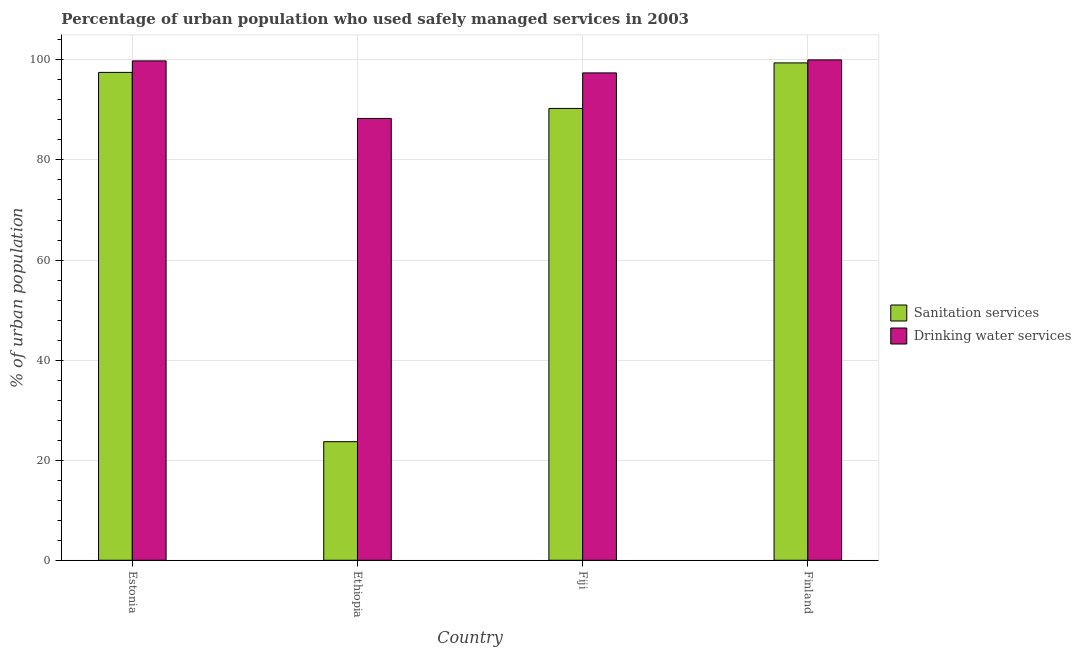What is the label of the 2nd group of bars from the left?
Offer a terse response. Ethiopia. What is the percentage of urban population who used sanitation services in Fiji?
Your answer should be compact. 90.3. Across all countries, what is the maximum percentage of urban population who used drinking water services?
Offer a very short reply. 100. Across all countries, what is the minimum percentage of urban population who used sanitation services?
Make the answer very short. 23.7. In which country was the percentage of urban population who used sanitation services minimum?
Offer a very short reply. Ethiopia. What is the total percentage of urban population who used drinking water services in the graph?
Keep it short and to the point. 385.5. What is the difference between the percentage of urban population who used drinking water services in Estonia and that in Fiji?
Provide a succinct answer. 2.4. What is the difference between the percentage of urban population who used sanitation services in Estonia and the percentage of urban population who used drinking water services in Finland?
Provide a succinct answer. -2.5. What is the average percentage of urban population who used sanitation services per country?
Provide a succinct answer. 77.72. What is the difference between the percentage of urban population who used sanitation services and percentage of urban population who used drinking water services in Fiji?
Offer a very short reply. -7.1. What is the ratio of the percentage of urban population who used sanitation services in Estonia to that in Ethiopia?
Offer a terse response. 4.11. Is the percentage of urban population who used sanitation services in Fiji less than that in Finland?
Your response must be concise. Yes. Is the difference between the percentage of urban population who used drinking water services in Ethiopia and Finland greater than the difference between the percentage of urban population who used sanitation services in Ethiopia and Finland?
Make the answer very short. Yes. What is the difference between the highest and the second highest percentage of urban population who used drinking water services?
Your response must be concise. 0.2. What is the difference between the highest and the lowest percentage of urban population who used drinking water services?
Your answer should be very brief. 11.7. What does the 1st bar from the left in Finland represents?
Your answer should be very brief. Sanitation services. What does the 1st bar from the right in Estonia represents?
Provide a succinct answer. Drinking water services. How many bars are there?
Provide a succinct answer. 8. How many countries are there in the graph?
Offer a terse response. 4. Are the values on the major ticks of Y-axis written in scientific E-notation?
Your answer should be compact. No. Does the graph contain any zero values?
Your answer should be very brief. No. What is the title of the graph?
Your response must be concise. Percentage of urban population who used safely managed services in 2003. What is the label or title of the X-axis?
Offer a very short reply. Country. What is the label or title of the Y-axis?
Offer a very short reply. % of urban population. What is the % of urban population in Sanitation services in Estonia?
Provide a succinct answer. 97.5. What is the % of urban population in Drinking water services in Estonia?
Provide a short and direct response. 99.8. What is the % of urban population of Sanitation services in Ethiopia?
Your answer should be compact. 23.7. What is the % of urban population in Drinking water services in Ethiopia?
Keep it short and to the point. 88.3. What is the % of urban population in Sanitation services in Fiji?
Give a very brief answer. 90.3. What is the % of urban population in Drinking water services in Fiji?
Provide a succinct answer. 97.4. What is the % of urban population of Sanitation services in Finland?
Your answer should be very brief. 99.4. What is the % of urban population of Drinking water services in Finland?
Your response must be concise. 100. Across all countries, what is the maximum % of urban population of Sanitation services?
Make the answer very short. 99.4. Across all countries, what is the minimum % of urban population of Sanitation services?
Keep it short and to the point. 23.7. Across all countries, what is the minimum % of urban population of Drinking water services?
Ensure brevity in your answer.  88.3. What is the total % of urban population in Sanitation services in the graph?
Your response must be concise. 310.9. What is the total % of urban population of Drinking water services in the graph?
Provide a short and direct response. 385.5. What is the difference between the % of urban population in Sanitation services in Estonia and that in Ethiopia?
Ensure brevity in your answer.  73.8. What is the difference between the % of urban population in Sanitation services in Estonia and that in Finland?
Offer a terse response. -1.9. What is the difference between the % of urban population of Drinking water services in Estonia and that in Finland?
Your answer should be very brief. -0.2. What is the difference between the % of urban population in Sanitation services in Ethiopia and that in Fiji?
Ensure brevity in your answer.  -66.6. What is the difference between the % of urban population in Drinking water services in Ethiopia and that in Fiji?
Make the answer very short. -9.1. What is the difference between the % of urban population of Sanitation services in Ethiopia and that in Finland?
Your answer should be very brief. -75.7. What is the difference between the % of urban population in Sanitation services in Fiji and that in Finland?
Provide a short and direct response. -9.1. What is the difference between the % of urban population in Drinking water services in Fiji and that in Finland?
Provide a succinct answer. -2.6. What is the difference between the % of urban population of Sanitation services in Estonia and the % of urban population of Drinking water services in Fiji?
Provide a succinct answer. 0.1. What is the difference between the % of urban population of Sanitation services in Ethiopia and the % of urban population of Drinking water services in Fiji?
Keep it short and to the point. -73.7. What is the difference between the % of urban population of Sanitation services in Ethiopia and the % of urban population of Drinking water services in Finland?
Your answer should be very brief. -76.3. What is the difference between the % of urban population in Sanitation services in Fiji and the % of urban population in Drinking water services in Finland?
Your answer should be compact. -9.7. What is the average % of urban population in Sanitation services per country?
Your answer should be compact. 77.72. What is the average % of urban population of Drinking water services per country?
Make the answer very short. 96.38. What is the difference between the % of urban population in Sanitation services and % of urban population in Drinking water services in Estonia?
Keep it short and to the point. -2.3. What is the difference between the % of urban population of Sanitation services and % of urban population of Drinking water services in Ethiopia?
Your answer should be very brief. -64.6. What is the difference between the % of urban population in Sanitation services and % of urban population in Drinking water services in Fiji?
Your response must be concise. -7.1. What is the ratio of the % of urban population in Sanitation services in Estonia to that in Ethiopia?
Offer a terse response. 4.11. What is the ratio of the % of urban population of Drinking water services in Estonia to that in Ethiopia?
Give a very brief answer. 1.13. What is the ratio of the % of urban population of Sanitation services in Estonia to that in Fiji?
Offer a terse response. 1.08. What is the ratio of the % of urban population in Drinking water services in Estonia to that in Fiji?
Make the answer very short. 1.02. What is the ratio of the % of urban population of Sanitation services in Estonia to that in Finland?
Offer a very short reply. 0.98. What is the ratio of the % of urban population of Sanitation services in Ethiopia to that in Fiji?
Your response must be concise. 0.26. What is the ratio of the % of urban population in Drinking water services in Ethiopia to that in Fiji?
Provide a succinct answer. 0.91. What is the ratio of the % of urban population in Sanitation services in Ethiopia to that in Finland?
Offer a very short reply. 0.24. What is the ratio of the % of urban population of Drinking water services in Ethiopia to that in Finland?
Your response must be concise. 0.88. What is the ratio of the % of urban population of Sanitation services in Fiji to that in Finland?
Offer a terse response. 0.91. What is the ratio of the % of urban population of Drinking water services in Fiji to that in Finland?
Give a very brief answer. 0.97. What is the difference between the highest and the lowest % of urban population of Sanitation services?
Make the answer very short. 75.7. 